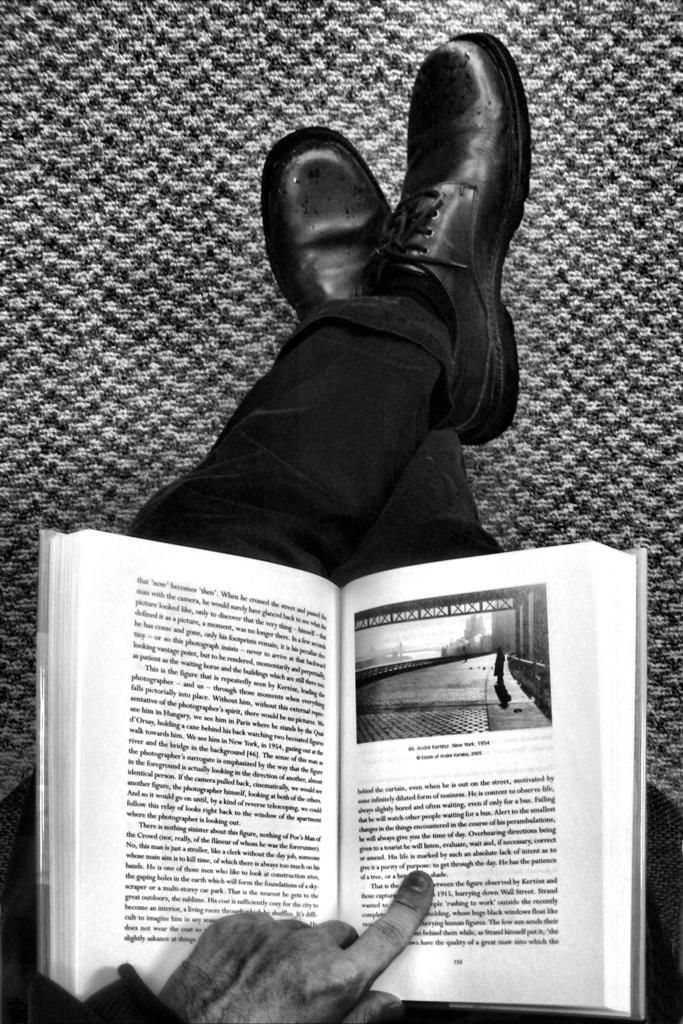What is the color scheme of the image? The image is black and white. What object can be seen on the person's lap in the image? There is a book on the person's lap in the image. What type of oatmeal is being prepared in the image? There is no oatmeal or any indication of food preparation in the image. What is the person in the image thinking about? We cannot determine what the person in the image is thinking about, as thoughts are not visible. 